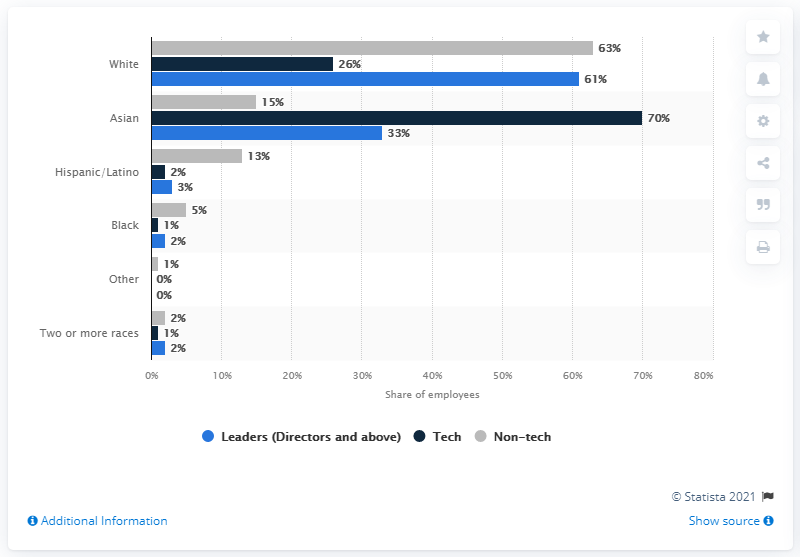Point out several critical features in this image. eBay's majority of employees were white. 